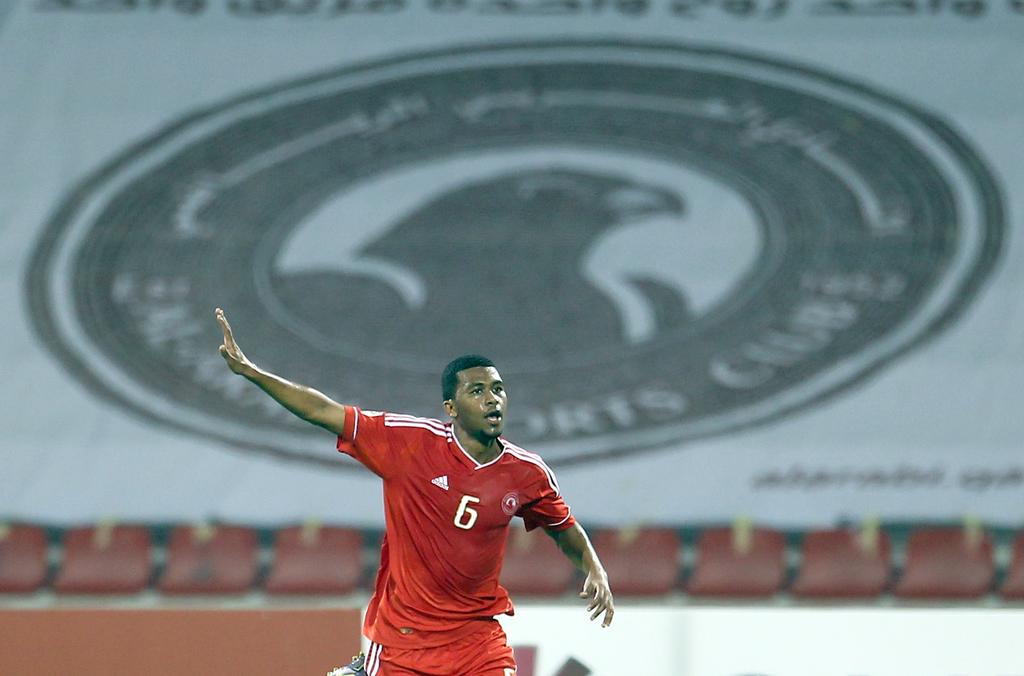What brand is on the jersey to the left of the 6?
Offer a terse response. Adidas. What number is written on the mans shirt?
Ensure brevity in your answer.  6. 